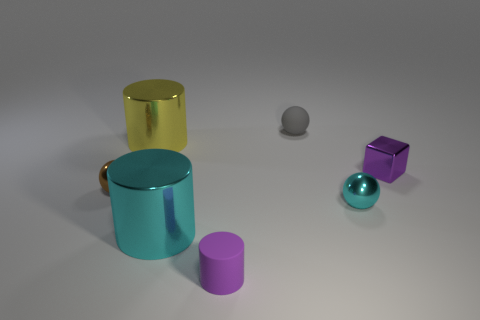Add 3 brown rubber things. How many objects exist? 10 Subtract all cylinders. How many objects are left? 4 Subtract all large blue matte cylinders. Subtract all small shiny cubes. How many objects are left? 6 Add 3 blocks. How many blocks are left? 4 Add 1 tiny metallic spheres. How many tiny metallic spheres exist? 3 Subtract 0 blue cubes. How many objects are left? 7 